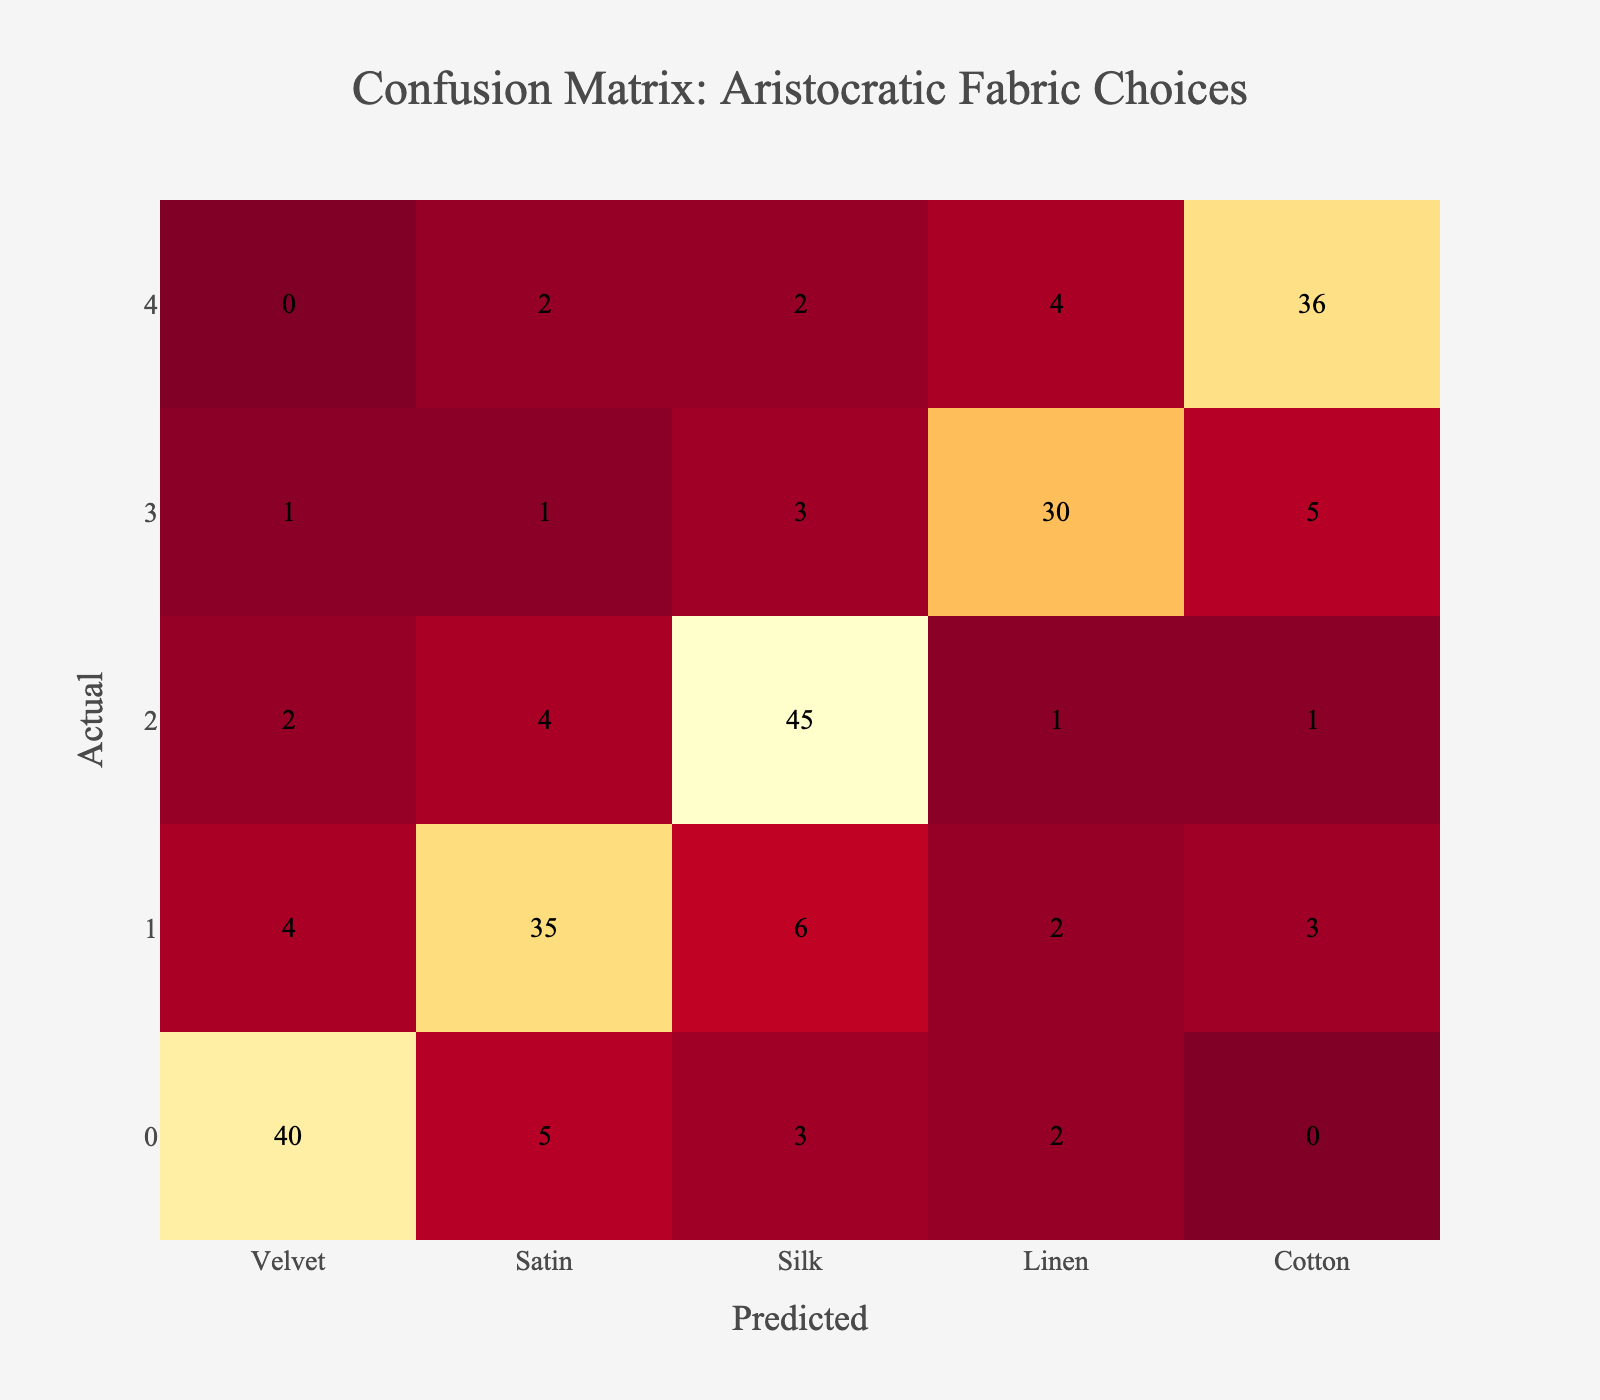What is the predicted count for Velvet when the actual fabric is Satin? The table indicates that when the actual fabric is Satin, the predicted count for Velvet is 4.
Answer: 4 What is the total number of predictions classified as Linen? To find the total predictions classified as Linen, we need to sum the values in the Linen row: 1 (predicted as Velvet) + 1 (predicted as Satin) + 3 (predicted as Silk) + 30 (predicted as Linen) + 5 (predicted as Cotton) = 40.
Answer: 40 Is Silk ever misclassified as Cotton according to the data? By checking the Silk row in the table, we see that the predicted count for Cotton when the actual fabric is Silk is 1. Therefore, Silk is indeed misclassified as Cotton.
Answer: Yes What is the highest predicted count for Satin and who was it from? The highest predicted count for Satin is 35, which is when the actual fabric is also Satin.
Answer: 35 (Satin) What is the average misclassification rate for the fabrics based on this confusion matrix? Calculate the total misclassifications for each fabric: for Velvet, it's 5 + 3 + 2 + 0 = 10; for Satin, it's 4 + 6 + 2 + 3 = 15; for Silk, it's 2 + 4 + 1 + 1 = 8; for Linen, it's 1 + 1 + 3 + 5 = 10; for Cotton, it's 2 + 2 + 4 = 8. Total misclassifications = 10 + 15 + 8 + 10 + 8 = 51. The total number of samples is 40 + 35 + 45 + 30 + 36 = 186. The misclassification rate is 51/186 = approximately 0.274. Therefore, the average misclassification rate is about 27.4%.
Answer: 27.4% What is the predicted count for Satin when the actual fabric is Silk? The table shows that when the actual fabric is Silk, the predicted count for Satin is 4.
Answer: 4 